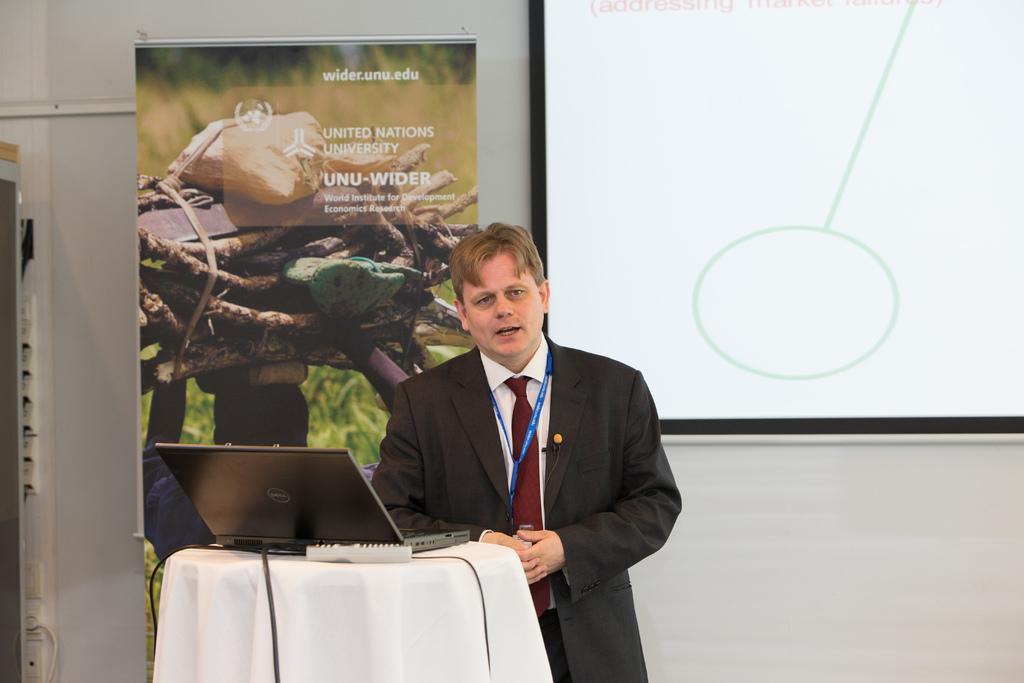How would you summarize this image in a sentence or two? In the foreground of this image, there is a man in suit is standing near a table on which a white cloth, remote and laptop are placed. In the background, there is a screen, banner and the wall. 